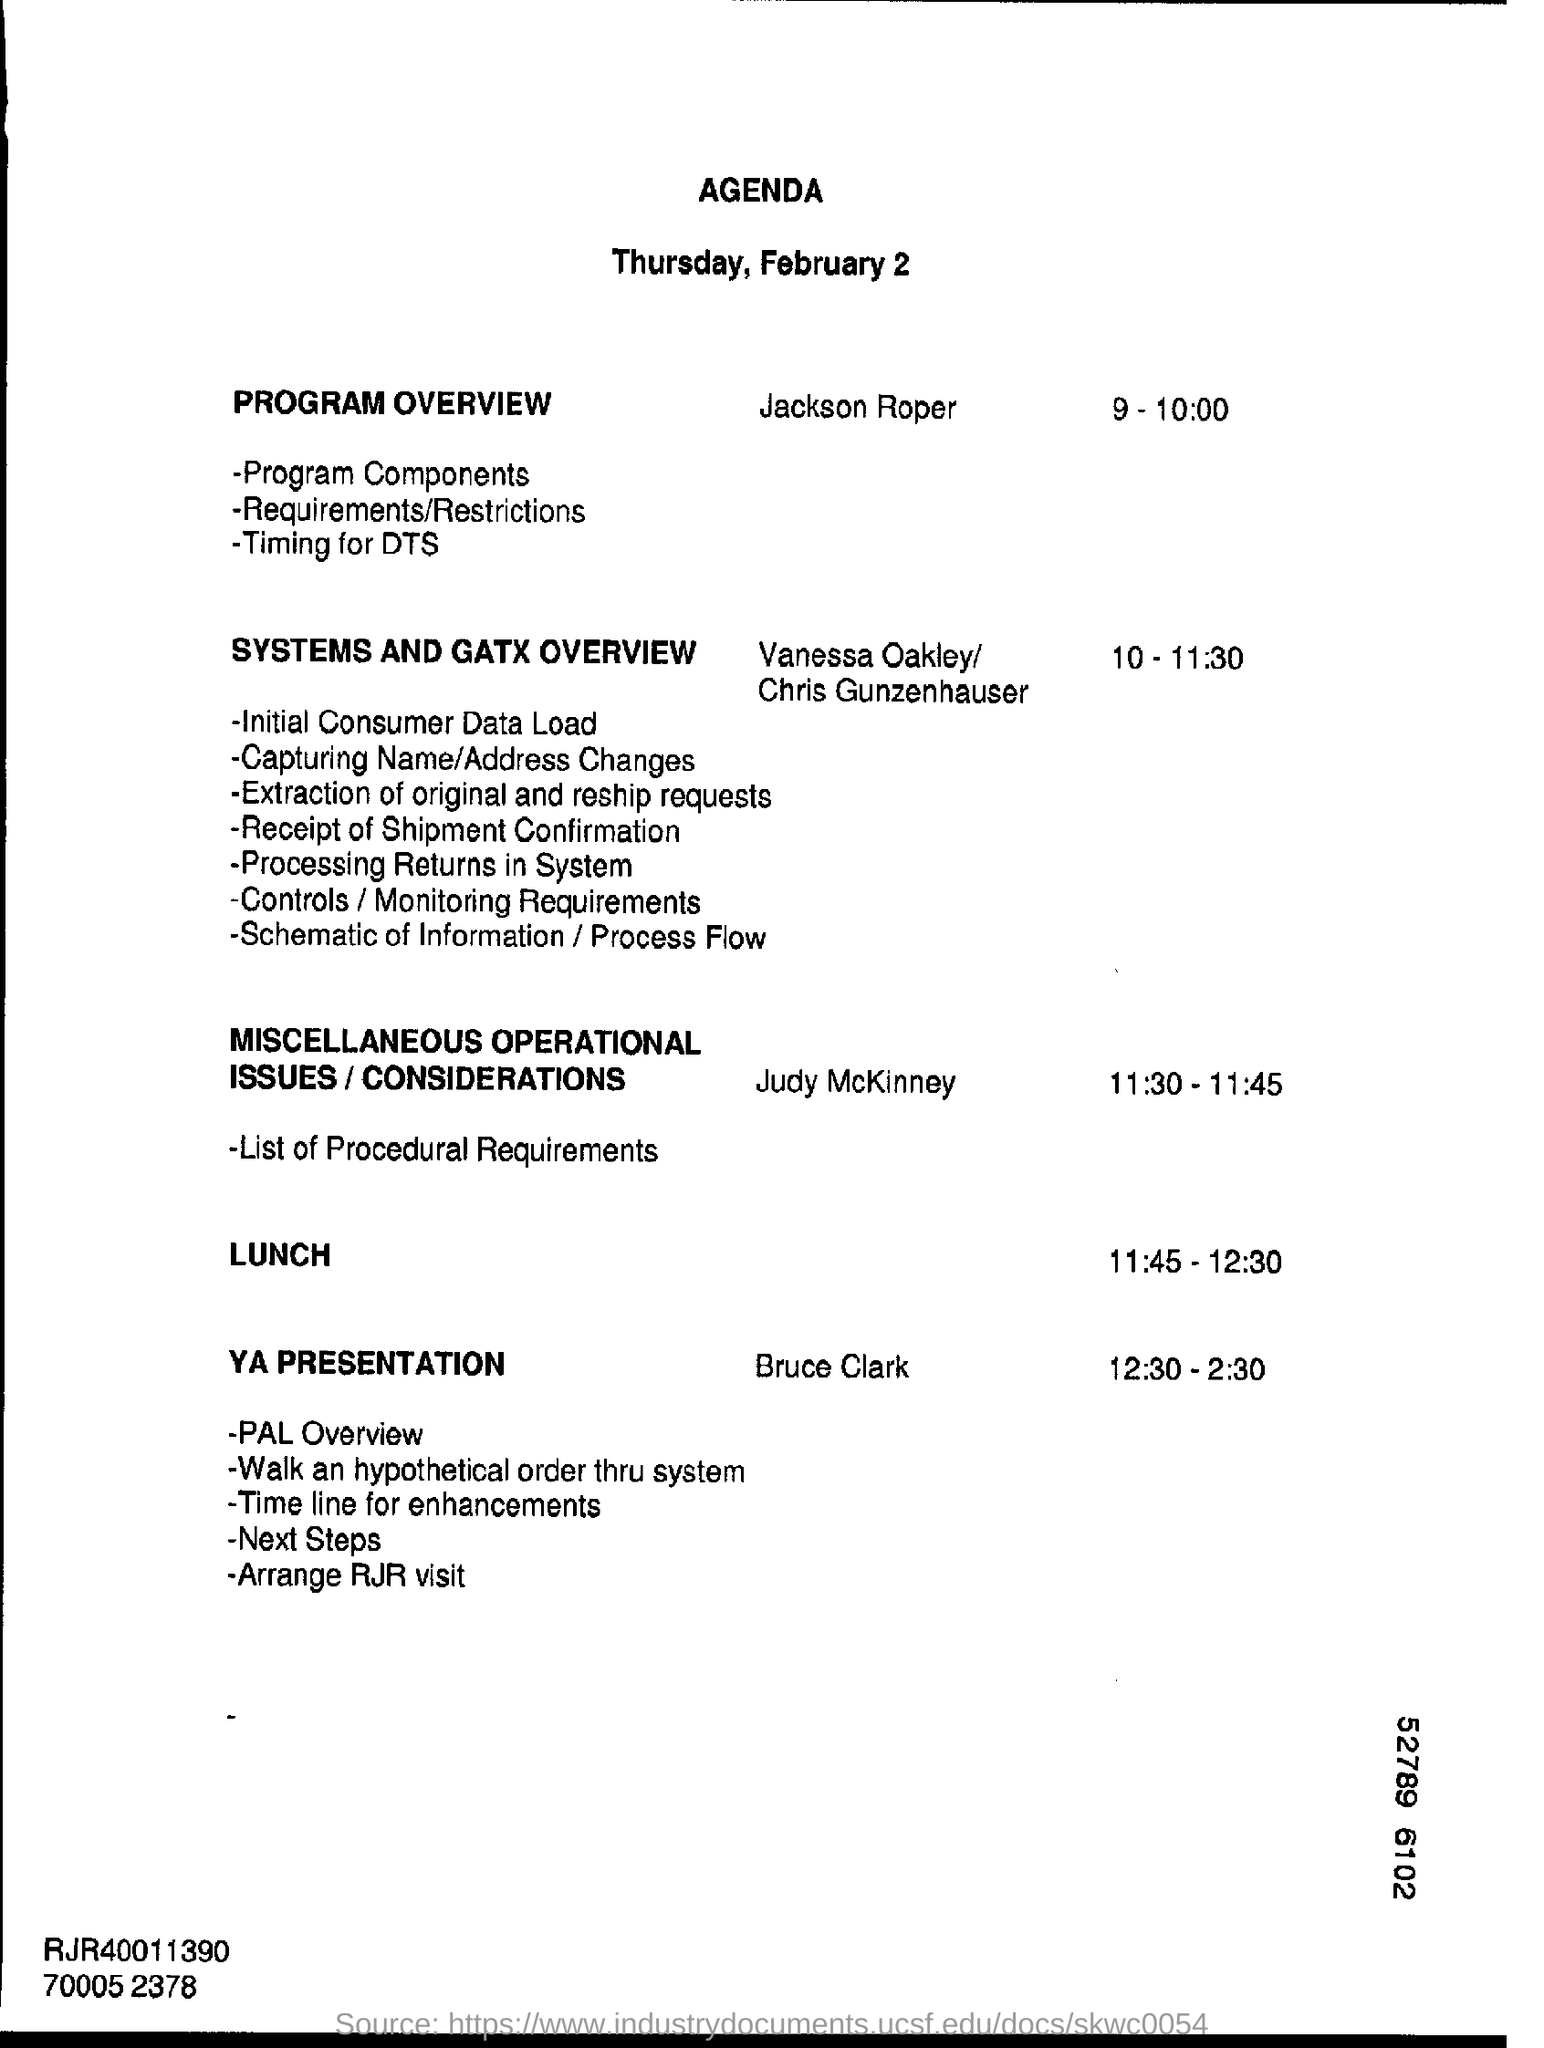Draw attention to some important aspects in this diagram. The date mentioned at the top of the document is Thursday, February 2. The lunch time as per the agenda is from 11:45 to 12:30. 